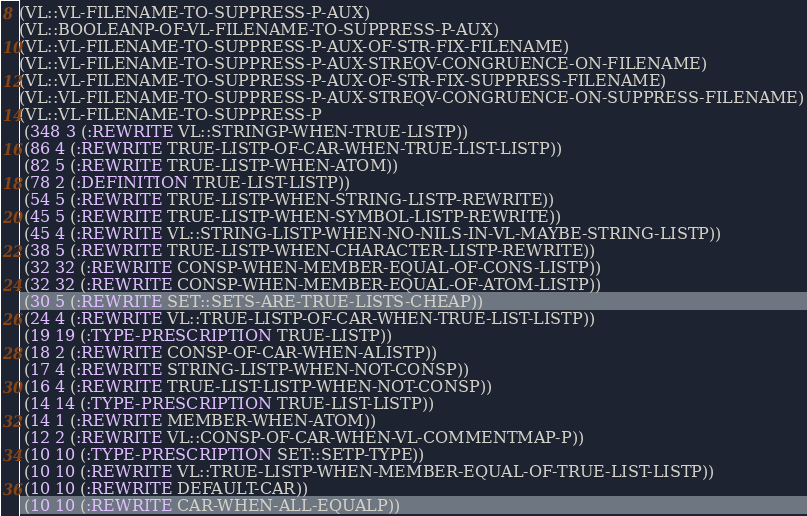<code> <loc_0><loc_0><loc_500><loc_500><_Lisp_>(VL::VL-FILENAME-TO-SUPPRESS-P-AUX)
(VL::BOOLEANP-OF-VL-FILENAME-TO-SUPPRESS-P-AUX)
(VL::VL-FILENAME-TO-SUPPRESS-P-AUX-OF-STR-FIX-FILENAME)
(VL::VL-FILENAME-TO-SUPPRESS-P-AUX-STREQV-CONGRUENCE-ON-FILENAME)
(VL::VL-FILENAME-TO-SUPPRESS-P-AUX-OF-STR-FIX-SUPPRESS-FILENAME)
(VL::VL-FILENAME-TO-SUPPRESS-P-AUX-STREQV-CONGRUENCE-ON-SUPPRESS-FILENAME)
(VL::VL-FILENAME-TO-SUPPRESS-P
 (348 3 (:REWRITE VL::STRINGP-WHEN-TRUE-LISTP))
 (86 4 (:REWRITE TRUE-LISTP-OF-CAR-WHEN-TRUE-LIST-LISTP))
 (82 5 (:REWRITE TRUE-LISTP-WHEN-ATOM))
 (78 2 (:DEFINITION TRUE-LIST-LISTP))
 (54 5 (:REWRITE TRUE-LISTP-WHEN-STRING-LISTP-REWRITE))
 (45 5 (:REWRITE TRUE-LISTP-WHEN-SYMBOL-LISTP-REWRITE))
 (45 4 (:REWRITE VL::STRING-LISTP-WHEN-NO-NILS-IN-VL-MAYBE-STRING-LISTP))
 (38 5 (:REWRITE TRUE-LISTP-WHEN-CHARACTER-LISTP-REWRITE))
 (32 32 (:REWRITE CONSP-WHEN-MEMBER-EQUAL-OF-CONS-LISTP))
 (32 32 (:REWRITE CONSP-WHEN-MEMBER-EQUAL-OF-ATOM-LISTP))
 (30 5 (:REWRITE SET::SETS-ARE-TRUE-LISTS-CHEAP))
 (24 4 (:REWRITE VL::TRUE-LISTP-OF-CAR-WHEN-TRUE-LIST-LISTP))
 (19 19 (:TYPE-PRESCRIPTION TRUE-LISTP))
 (18 2 (:REWRITE CONSP-OF-CAR-WHEN-ALISTP))
 (17 4 (:REWRITE STRING-LISTP-WHEN-NOT-CONSP))
 (16 4 (:REWRITE TRUE-LIST-LISTP-WHEN-NOT-CONSP))
 (14 14 (:TYPE-PRESCRIPTION TRUE-LIST-LISTP))
 (14 1 (:REWRITE MEMBER-WHEN-ATOM))
 (12 2 (:REWRITE VL::CONSP-OF-CAR-WHEN-VL-COMMENTMAP-P))
 (10 10 (:TYPE-PRESCRIPTION SET::SETP-TYPE))
 (10 10 (:REWRITE VL::TRUE-LISTP-WHEN-MEMBER-EQUAL-OF-TRUE-LIST-LISTP))
 (10 10 (:REWRITE DEFAULT-CAR))
 (10 10 (:REWRITE CAR-WHEN-ALL-EQUALP))</code> 